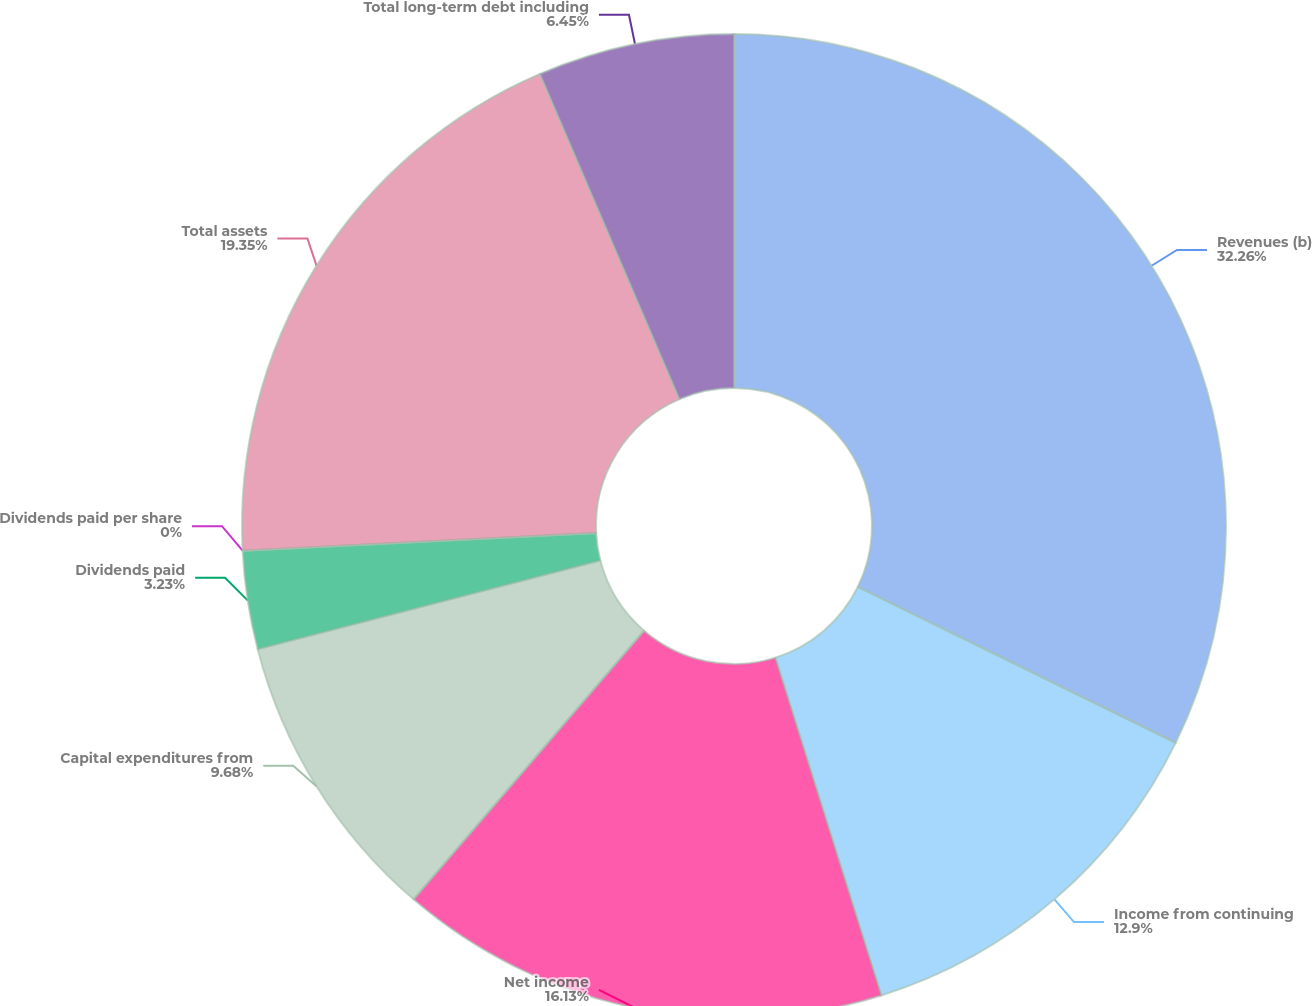Convert chart. <chart><loc_0><loc_0><loc_500><loc_500><pie_chart><fcel>Revenues (b)<fcel>Income from continuing<fcel>Net income<fcel>Capital expenditures from<fcel>Dividends paid<fcel>Dividends paid per share<fcel>Total assets<fcel>Total long-term debt including<nl><fcel>32.26%<fcel>12.9%<fcel>16.13%<fcel>9.68%<fcel>3.23%<fcel>0.0%<fcel>19.35%<fcel>6.45%<nl></chart> 